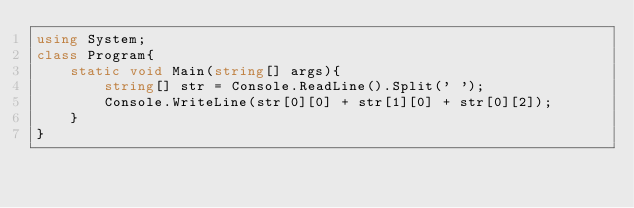Convert code to text. <code><loc_0><loc_0><loc_500><loc_500><_C#_>using System;
class Program{
    static void Main(string[] args){
        string[] str = Console.ReadLine().Split(' ');
        Console.WriteLine(str[0][0] + str[1][0] + str[0][2]);
    }
}</code> 